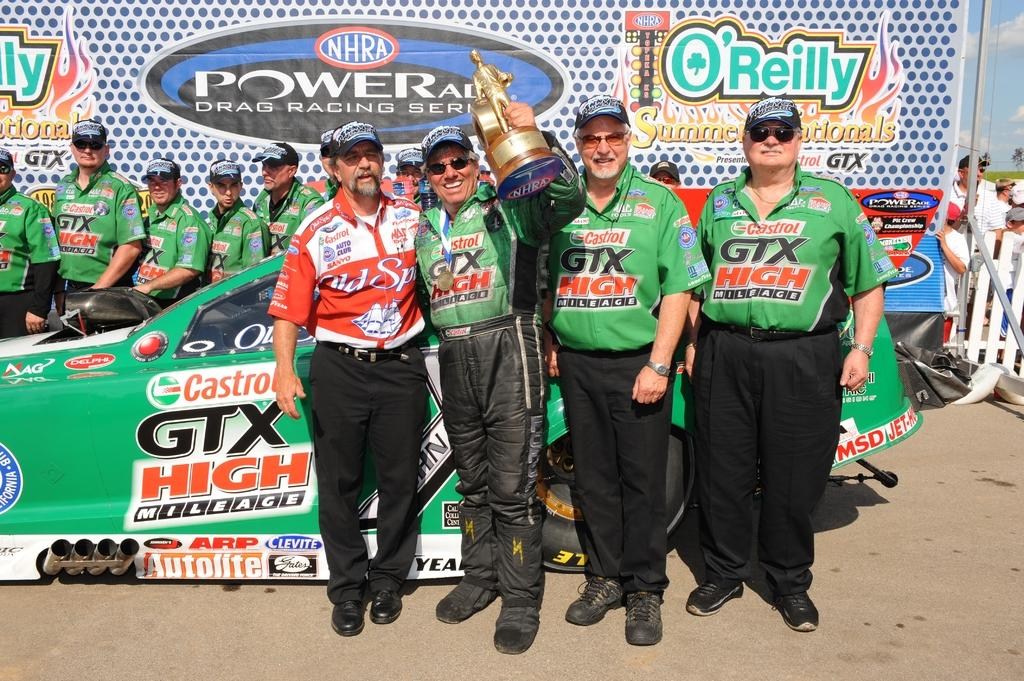<image>
Summarize the visual content of the image. The Castrol GTX team celebrates a drag racing victory in the winner's cicle 